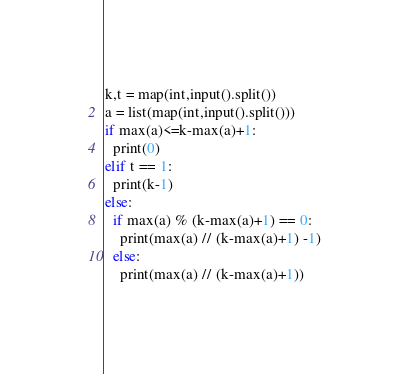Convert code to text. <code><loc_0><loc_0><loc_500><loc_500><_Python_>k,t = map(int,input().split())
a = list(map(int,input().split()))
if max(a)<=k-max(a)+1:
  print(0)
elif t == 1:
  print(k-1)
else:
  if max(a) % (k-max(a)+1) == 0:
    print(max(a) // (k-max(a)+1) -1)
  else:
    print(max(a) // (k-max(a)+1))</code> 